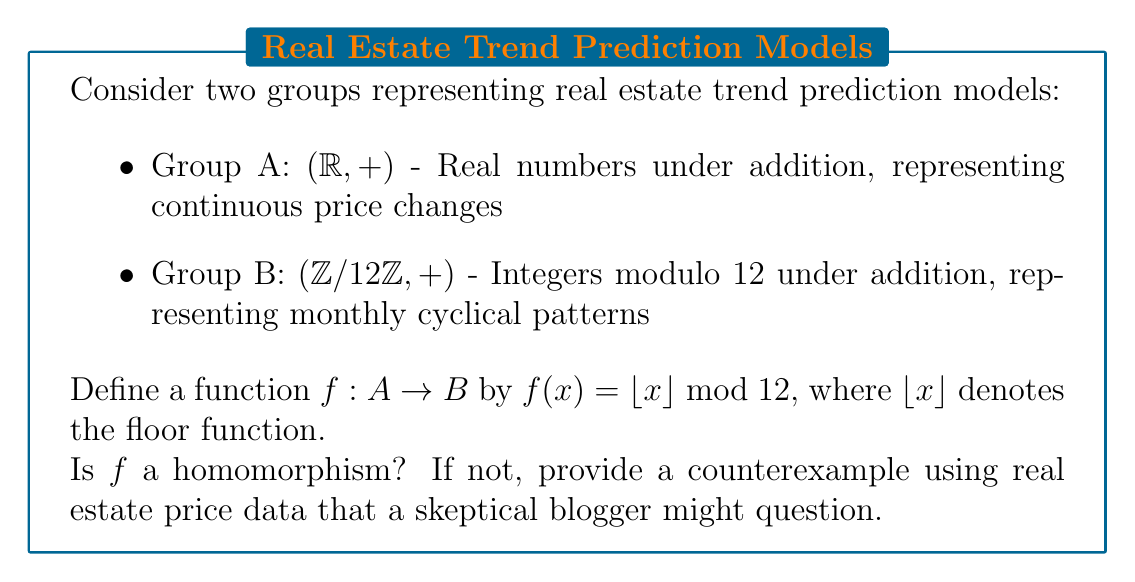Could you help me with this problem? To determine if $f$ is a homomorphism, we need to check if it satisfies the homomorphism property:

$f(x + y) = f(x) + f(y)$ for all $x, y \in A$

Let's approach this step-by-step:

1) First, let's consider two arbitrary elements $x$ and $y$ in $A$.

2) The left side of the equation would be:
   $f(x + y) = \lfloor x + y \rfloor \bmod 12$

3) The right side would be:
   $f(x) + f(y) = (\lfloor x \rfloor \bmod 12) + (\lfloor y \rfloor \bmod 12)$

4) These are not always equal. For a counterexample, consider:
   $x = 3.7$ (representing a 3.7% price increase)
   $y = 2.6$ (representing a 2.6% price increase)

5) Left side:
   $f(3.7 + 2.6) = f(6.3) = \lfloor 6.3 \rfloor \bmod 12 = 6 \bmod 12 = 6$

6) Right side:
   $f(3.7) + f(2.6) = (\lfloor 3.7 \rfloor \bmod 12) + (\lfloor 2.6 \rfloor \bmod 12)$
                    $= (3 \bmod 12) + (2 \bmod 12)$
                    $= 3 + 2 = 5$

7) Since $6 \neq 5$, $f$ is not a homomorphism.

This counterexample demonstrates how rounding in real estate price predictions can lead to discrepancies, which a skeptical blogger might use to question the accuracy of trend prediction models that oversimplify continuous data into discrete categories.
Answer: Not a homomorphism; $f(3.7 + 2.6) \neq f(3.7) + f(2.6)$ 